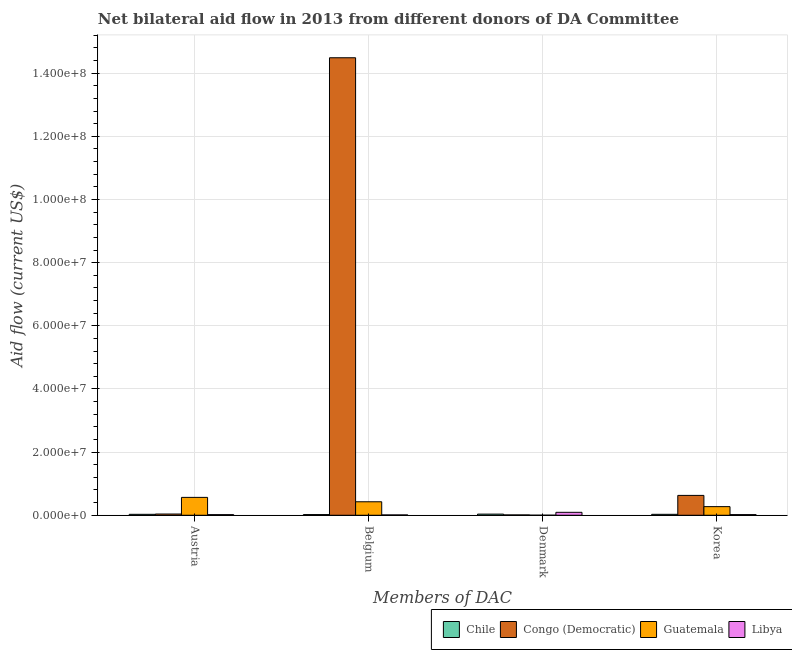Are the number of bars per tick equal to the number of legend labels?
Give a very brief answer. Yes. Are the number of bars on each tick of the X-axis equal?
Your response must be concise. Yes. How many bars are there on the 2nd tick from the left?
Ensure brevity in your answer.  4. What is the amount of aid given by korea in Libya?
Give a very brief answer. 2.10e+05. Across all countries, what is the maximum amount of aid given by denmark?
Keep it short and to the point. 9.30e+05. Across all countries, what is the minimum amount of aid given by korea?
Keep it short and to the point. 2.10e+05. In which country was the amount of aid given by korea maximum?
Offer a terse response. Congo (Democratic). In which country was the amount of aid given by korea minimum?
Make the answer very short. Libya. What is the total amount of aid given by korea in the graph?
Keep it short and to the point. 9.53e+06. What is the difference between the amount of aid given by austria in Chile and that in Congo (Democratic)?
Make the answer very short. -9.00e+04. What is the difference between the amount of aid given by denmark in Libya and the amount of aid given by belgium in Congo (Democratic)?
Your answer should be compact. -1.44e+08. What is the average amount of aid given by denmark per country?
Keep it short and to the point. 3.55e+05. What is the difference between the amount of aid given by belgium and amount of aid given by denmark in Guatemala?
Keep it short and to the point. 4.25e+06. In how many countries, is the amount of aid given by korea greater than 88000000 US$?
Your answer should be compact. 0. What is the ratio of the amount of aid given by denmark in Chile to that in Libya?
Your answer should be very brief. 0.39. Is the amount of aid given by korea in Congo (Democratic) less than that in Chile?
Your response must be concise. No. What is the difference between the highest and the second highest amount of aid given by belgium?
Provide a succinct answer. 1.41e+08. What is the difference between the highest and the lowest amount of aid given by korea?
Your answer should be very brief. 6.08e+06. Is the sum of the amount of aid given by belgium in Libya and Chile greater than the maximum amount of aid given by denmark across all countries?
Provide a short and direct response. No. Is it the case that in every country, the sum of the amount of aid given by austria and amount of aid given by belgium is greater than the sum of amount of aid given by korea and amount of aid given by denmark?
Your answer should be very brief. No. What does the 1st bar from the right in Austria represents?
Make the answer very short. Libya. Is it the case that in every country, the sum of the amount of aid given by austria and amount of aid given by belgium is greater than the amount of aid given by denmark?
Make the answer very short. No. How many bars are there?
Keep it short and to the point. 16. Are all the bars in the graph horizontal?
Keep it short and to the point. No. What is the difference between two consecutive major ticks on the Y-axis?
Provide a short and direct response. 2.00e+07. Where does the legend appear in the graph?
Ensure brevity in your answer.  Bottom right. How many legend labels are there?
Give a very brief answer. 4. What is the title of the graph?
Your response must be concise. Net bilateral aid flow in 2013 from different donors of DA Committee. What is the label or title of the X-axis?
Provide a succinct answer. Members of DAC. What is the label or title of the Y-axis?
Make the answer very short. Aid flow (current US$). What is the Aid flow (current US$) of Chile in Austria?
Your answer should be compact. 3.00e+05. What is the Aid flow (current US$) of Guatemala in Austria?
Ensure brevity in your answer.  5.66e+06. What is the Aid flow (current US$) of Libya in Austria?
Provide a succinct answer. 2.00e+05. What is the Aid flow (current US$) of Congo (Democratic) in Belgium?
Provide a short and direct response. 1.45e+08. What is the Aid flow (current US$) in Guatemala in Belgium?
Give a very brief answer. 4.27e+06. What is the Aid flow (current US$) of Guatemala in Denmark?
Make the answer very short. 2.00e+04. What is the Aid flow (current US$) of Libya in Denmark?
Keep it short and to the point. 9.30e+05. What is the Aid flow (current US$) of Congo (Democratic) in Korea?
Provide a short and direct response. 6.29e+06. What is the Aid flow (current US$) of Guatemala in Korea?
Offer a very short reply. 2.73e+06. What is the Aid flow (current US$) of Libya in Korea?
Make the answer very short. 2.10e+05. Across all Members of DAC, what is the maximum Aid flow (current US$) of Chile?
Keep it short and to the point. 3.60e+05. Across all Members of DAC, what is the maximum Aid flow (current US$) of Congo (Democratic)?
Your answer should be compact. 1.45e+08. Across all Members of DAC, what is the maximum Aid flow (current US$) in Guatemala?
Ensure brevity in your answer.  5.66e+06. Across all Members of DAC, what is the maximum Aid flow (current US$) of Libya?
Your answer should be compact. 9.30e+05. Across all Members of DAC, what is the minimum Aid flow (current US$) in Libya?
Provide a short and direct response. 1.10e+05. What is the total Aid flow (current US$) of Chile in the graph?
Provide a short and direct response. 1.18e+06. What is the total Aid flow (current US$) of Congo (Democratic) in the graph?
Give a very brief answer. 1.52e+08. What is the total Aid flow (current US$) of Guatemala in the graph?
Your response must be concise. 1.27e+07. What is the total Aid flow (current US$) of Libya in the graph?
Give a very brief answer. 1.45e+06. What is the difference between the Aid flow (current US$) of Chile in Austria and that in Belgium?
Keep it short and to the point. 8.00e+04. What is the difference between the Aid flow (current US$) of Congo (Democratic) in Austria and that in Belgium?
Your answer should be very brief. -1.44e+08. What is the difference between the Aid flow (current US$) of Guatemala in Austria and that in Belgium?
Offer a terse response. 1.39e+06. What is the difference between the Aid flow (current US$) of Chile in Austria and that in Denmark?
Offer a very short reply. -6.00e+04. What is the difference between the Aid flow (current US$) in Congo (Democratic) in Austria and that in Denmark?
Ensure brevity in your answer.  2.80e+05. What is the difference between the Aid flow (current US$) of Guatemala in Austria and that in Denmark?
Your answer should be very brief. 5.64e+06. What is the difference between the Aid flow (current US$) of Libya in Austria and that in Denmark?
Keep it short and to the point. -7.30e+05. What is the difference between the Aid flow (current US$) in Chile in Austria and that in Korea?
Make the answer very short. 0. What is the difference between the Aid flow (current US$) of Congo (Democratic) in Austria and that in Korea?
Offer a very short reply. -5.90e+06. What is the difference between the Aid flow (current US$) of Guatemala in Austria and that in Korea?
Provide a short and direct response. 2.93e+06. What is the difference between the Aid flow (current US$) in Chile in Belgium and that in Denmark?
Offer a very short reply. -1.40e+05. What is the difference between the Aid flow (current US$) in Congo (Democratic) in Belgium and that in Denmark?
Offer a very short reply. 1.45e+08. What is the difference between the Aid flow (current US$) of Guatemala in Belgium and that in Denmark?
Your answer should be very brief. 4.25e+06. What is the difference between the Aid flow (current US$) in Libya in Belgium and that in Denmark?
Your response must be concise. -8.20e+05. What is the difference between the Aid flow (current US$) in Chile in Belgium and that in Korea?
Ensure brevity in your answer.  -8.00e+04. What is the difference between the Aid flow (current US$) of Congo (Democratic) in Belgium and that in Korea?
Make the answer very short. 1.39e+08. What is the difference between the Aid flow (current US$) of Guatemala in Belgium and that in Korea?
Your answer should be compact. 1.54e+06. What is the difference between the Aid flow (current US$) of Congo (Democratic) in Denmark and that in Korea?
Provide a short and direct response. -6.18e+06. What is the difference between the Aid flow (current US$) of Guatemala in Denmark and that in Korea?
Your answer should be compact. -2.71e+06. What is the difference between the Aid flow (current US$) of Libya in Denmark and that in Korea?
Offer a very short reply. 7.20e+05. What is the difference between the Aid flow (current US$) in Chile in Austria and the Aid flow (current US$) in Congo (Democratic) in Belgium?
Offer a terse response. -1.45e+08. What is the difference between the Aid flow (current US$) of Chile in Austria and the Aid flow (current US$) of Guatemala in Belgium?
Ensure brevity in your answer.  -3.97e+06. What is the difference between the Aid flow (current US$) of Congo (Democratic) in Austria and the Aid flow (current US$) of Guatemala in Belgium?
Ensure brevity in your answer.  -3.88e+06. What is the difference between the Aid flow (current US$) in Guatemala in Austria and the Aid flow (current US$) in Libya in Belgium?
Your answer should be compact. 5.55e+06. What is the difference between the Aid flow (current US$) of Chile in Austria and the Aid flow (current US$) of Guatemala in Denmark?
Your answer should be compact. 2.80e+05. What is the difference between the Aid flow (current US$) of Chile in Austria and the Aid flow (current US$) of Libya in Denmark?
Make the answer very short. -6.30e+05. What is the difference between the Aid flow (current US$) in Congo (Democratic) in Austria and the Aid flow (current US$) in Libya in Denmark?
Your answer should be very brief. -5.40e+05. What is the difference between the Aid flow (current US$) in Guatemala in Austria and the Aid flow (current US$) in Libya in Denmark?
Your response must be concise. 4.73e+06. What is the difference between the Aid flow (current US$) in Chile in Austria and the Aid flow (current US$) in Congo (Democratic) in Korea?
Your response must be concise. -5.99e+06. What is the difference between the Aid flow (current US$) of Chile in Austria and the Aid flow (current US$) of Guatemala in Korea?
Your answer should be compact. -2.43e+06. What is the difference between the Aid flow (current US$) in Congo (Democratic) in Austria and the Aid flow (current US$) in Guatemala in Korea?
Keep it short and to the point. -2.34e+06. What is the difference between the Aid flow (current US$) in Congo (Democratic) in Austria and the Aid flow (current US$) in Libya in Korea?
Offer a very short reply. 1.80e+05. What is the difference between the Aid flow (current US$) of Guatemala in Austria and the Aid flow (current US$) of Libya in Korea?
Your response must be concise. 5.45e+06. What is the difference between the Aid flow (current US$) of Chile in Belgium and the Aid flow (current US$) of Guatemala in Denmark?
Provide a short and direct response. 2.00e+05. What is the difference between the Aid flow (current US$) in Chile in Belgium and the Aid flow (current US$) in Libya in Denmark?
Give a very brief answer. -7.10e+05. What is the difference between the Aid flow (current US$) of Congo (Democratic) in Belgium and the Aid flow (current US$) of Guatemala in Denmark?
Keep it short and to the point. 1.45e+08. What is the difference between the Aid flow (current US$) in Congo (Democratic) in Belgium and the Aid flow (current US$) in Libya in Denmark?
Offer a very short reply. 1.44e+08. What is the difference between the Aid flow (current US$) of Guatemala in Belgium and the Aid flow (current US$) of Libya in Denmark?
Offer a terse response. 3.34e+06. What is the difference between the Aid flow (current US$) in Chile in Belgium and the Aid flow (current US$) in Congo (Democratic) in Korea?
Offer a terse response. -6.07e+06. What is the difference between the Aid flow (current US$) of Chile in Belgium and the Aid flow (current US$) of Guatemala in Korea?
Provide a short and direct response. -2.51e+06. What is the difference between the Aid flow (current US$) of Chile in Belgium and the Aid flow (current US$) of Libya in Korea?
Offer a very short reply. 10000. What is the difference between the Aid flow (current US$) of Congo (Democratic) in Belgium and the Aid flow (current US$) of Guatemala in Korea?
Your answer should be compact. 1.42e+08. What is the difference between the Aid flow (current US$) in Congo (Democratic) in Belgium and the Aid flow (current US$) in Libya in Korea?
Your answer should be very brief. 1.45e+08. What is the difference between the Aid flow (current US$) of Guatemala in Belgium and the Aid flow (current US$) of Libya in Korea?
Offer a terse response. 4.06e+06. What is the difference between the Aid flow (current US$) in Chile in Denmark and the Aid flow (current US$) in Congo (Democratic) in Korea?
Offer a very short reply. -5.93e+06. What is the difference between the Aid flow (current US$) of Chile in Denmark and the Aid flow (current US$) of Guatemala in Korea?
Your response must be concise. -2.37e+06. What is the difference between the Aid flow (current US$) in Chile in Denmark and the Aid flow (current US$) in Libya in Korea?
Offer a very short reply. 1.50e+05. What is the difference between the Aid flow (current US$) of Congo (Democratic) in Denmark and the Aid flow (current US$) of Guatemala in Korea?
Offer a very short reply. -2.62e+06. What is the difference between the Aid flow (current US$) in Congo (Democratic) in Denmark and the Aid flow (current US$) in Libya in Korea?
Ensure brevity in your answer.  -1.00e+05. What is the average Aid flow (current US$) of Chile per Members of DAC?
Your answer should be compact. 2.95e+05. What is the average Aid flow (current US$) of Congo (Democratic) per Members of DAC?
Offer a very short reply. 3.79e+07. What is the average Aid flow (current US$) in Guatemala per Members of DAC?
Offer a very short reply. 3.17e+06. What is the average Aid flow (current US$) in Libya per Members of DAC?
Offer a terse response. 3.62e+05. What is the difference between the Aid flow (current US$) of Chile and Aid flow (current US$) of Guatemala in Austria?
Offer a very short reply. -5.36e+06. What is the difference between the Aid flow (current US$) in Chile and Aid flow (current US$) in Libya in Austria?
Your answer should be very brief. 1.00e+05. What is the difference between the Aid flow (current US$) of Congo (Democratic) and Aid flow (current US$) of Guatemala in Austria?
Your answer should be very brief. -5.27e+06. What is the difference between the Aid flow (current US$) in Congo (Democratic) and Aid flow (current US$) in Libya in Austria?
Provide a succinct answer. 1.90e+05. What is the difference between the Aid flow (current US$) of Guatemala and Aid flow (current US$) of Libya in Austria?
Offer a terse response. 5.46e+06. What is the difference between the Aid flow (current US$) in Chile and Aid flow (current US$) in Congo (Democratic) in Belgium?
Offer a terse response. -1.45e+08. What is the difference between the Aid flow (current US$) in Chile and Aid flow (current US$) in Guatemala in Belgium?
Your response must be concise. -4.05e+06. What is the difference between the Aid flow (current US$) in Congo (Democratic) and Aid flow (current US$) in Guatemala in Belgium?
Your answer should be compact. 1.41e+08. What is the difference between the Aid flow (current US$) in Congo (Democratic) and Aid flow (current US$) in Libya in Belgium?
Your response must be concise. 1.45e+08. What is the difference between the Aid flow (current US$) of Guatemala and Aid flow (current US$) of Libya in Belgium?
Offer a very short reply. 4.16e+06. What is the difference between the Aid flow (current US$) of Chile and Aid flow (current US$) of Congo (Democratic) in Denmark?
Your response must be concise. 2.50e+05. What is the difference between the Aid flow (current US$) in Chile and Aid flow (current US$) in Guatemala in Denmark?
Your answer should be very brief. 3.40e+05. What is the difference between the Aid flow (current US$) in Chile and Aid flow (current US$) in Libya in Denmark?
Your response must be concise. -5.70e+05. What is the difference between the Aid flow (current US$) in Congo (Democratic) and Aid flow (current US$) in Guatemala in Denmark?
Provide a short and direct response. 9.00e+04. What is the difference between the Aid flow (current US$) of Congo (Democratic) and Aid flow (current US$) of Libya in Denmark?
Provide a succinct answer. -8.20e+05. What is the difference between the Aid flow (current US$) of Guatemala and Aid flow (current US$) of Libya in Denmark?
Provide a short and direct response. -9.10e+05. What is the difference between the Aid flow (current US$) of Chile and Aid flow (current US$) of Congo (Democratic) in Korea?
Your answer should be very brief. -5.99e+06. What is the difference between the Aid flow (current US$) in Chile and Aid flow (current US$) in Guatemala in Korea?
Your answer should be compact. -2.43e+06. What is the difference between the Aid flow (current US$) in Chile and Aid flow (current US$) in Libya in Korea?
Your response must be concise. 9.00e+04. What is the difference between the Aid flow (current US$) in Congo (Democratic) and Aid flow (current US$) in Guatemala in Korea?
Make the answer very short. 3.56e+06. What is the difference between the Aid flow (current US$) of Congo (Democratic) and Aid flow (current US$) of Libya in Korea?
Your response must be concise. 6.08e+06. What is the difference between the Aid flow (current US$) of Guatemala and Aid flow (current US$) of Libya in Korea?
Give a very brief answer. 2.52e+06. What is the ratio of the Aid flow (current US$) in Chile in Austria to that in Belgium?
Provide a succinct answer. 1.36. What is the ratio of the Aid flow (current US$) of Congo (Democratic) in Austria to that in Belgium?
Offer a very short reply. 0. What is the ratio of the Aid flow (current US$) in Guatemala in Austria to that in Belgium?
Offer a very short reply. 1.33. What is the ratio of the Aid flow (current US$) in Libya in Austria to that in Belgium?
Give a very brief answer. 1.82. What is the ratio of the Aid flow (current US$) of Congo (Democratic) in Austria to that in Denmark?
Your answer should be compact. 3.55. What is the ratio of the Aid flow (current US$) of Guatemala in Austria to that in Denmark?
Provide a succinct answer. 283. What is the ratio of the Aid flow (current US$) in Libya in Austria to that in Denmark?
Your response must be concise. 0.22. What is the ratio of the Aid flow (current US$) of Chile in Austria to that in Korea?
Make the answer very short. 1. What is the ratio of the Aid flow (current US$) of Congo (Democratic) in Austria to that in Korea?
Provide a short and direct response. 0.06. What is the ratio of the Aid flow (current US$) of Guatemala in Austria to that in Korea?
Make the answer very short. 2.07. What is the ratio of the Aid flow (current US$) in Chile in Belgium to that in Denmark?
Give a very brief answer. 0.61. What is the ratio of the Aid flow (current US$) of Congo (Democratic) in Belgium to that in Denmark?
Give a very brief answer. 1317.18. What is the ratio of the Aid flow (current US$) in Guatemala in Belgium to that in Denmark?
Provide a short and direct response. 213.5. What is the ratio of the Aid flow (current US$) in Libya in Belgium to that in Denmark?
Your answer should be compact. 0.12. What is the ratio of the Aid flow (current US$) in Chile in Belgium to that in Korea?
Offer a terse response. 0.73. What is the ratio of the Aid flow (current US$) in Congo (Democratic) in Belgium to that in Korea?
Give a very brief answer. 23.04. What is the ratio of the Aid flow (current US$) in Guatemala in Belgium to that in Korea?
Provide a succinct answer. 1.56. What is the ratio of the Aid flow (current US$) in Libya in Belgium to that in Korea?
Give a very brief answer. 0.52. What is the ratio of the Aid flow (current US$) of Congo (Democratic) in Denmark to that in Korea?
Keep it short and to the point. 0.02. What is the ratio of the Aid flow (current US$) of Guatemala in Denmark to that in Korea?
Provide a short and direct response. 0.01. What is the ratio of the Aid flow (current US$) in Libya in Denmark to that in Korea?
Your answer should be compact. 4.43. What is the difference between the highest and the second highest Aid flow (current US$) in Chile?
Keep it short and to the point. 6.00e+04. What is the difference between the highest and the second highest Aid flow (current US$) of Congo (Democratic)?
Provide a succinct answer. 1.39e+08. What is the difference between the highest and the second highest Aid flow (current US$) of Guatemala?
Provide a succinct answer. 1.39e+06. What is the difference between the highest and the second highest Aid flow (current US$) of Libya?
Give a very brief answer. 7.20e+05. What is the difference between the highest and the lowest Aid flow (current US$) in Congo (Democratic)?
Ensure brevity in your answer.  1.45e+08. What is the difference between the highest and the lowest Aid flow (current US$) in Guatemala?
Your response must be concise. 5.64e+06. What is the difference between the highest and the lowest Aid flow (current US$) of Libya?
Your response must be concise. 8.20e+05. 